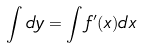Convert formula to latex. <formula><loc_0><loc_0><loc_500><loc_500>\int d y = \int f ^ { \prime } ( x ) d x</formula> 